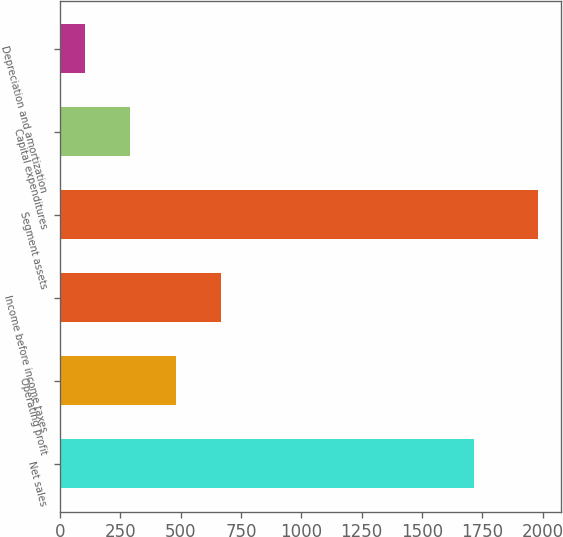<chart> <loc_0><loc_0><loc_500><loc_500><bar_chart><fcel>Net sales<fcel>Operating profit<fcel>Income before income taxes<fcel>Segment assets<fcel>Capital expenditures<fcel>Depreciation and amortization<nl><fcel>1717.4<fcel>479.3<fcel>666.75<fcel>1978.9<fcel>291.85<fcel>104.4<nl></chart> 